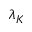Convert formula to latex. <formula><loc_0><loc_0><loc_500><loc_500>\lambda _ { K }</formula> 